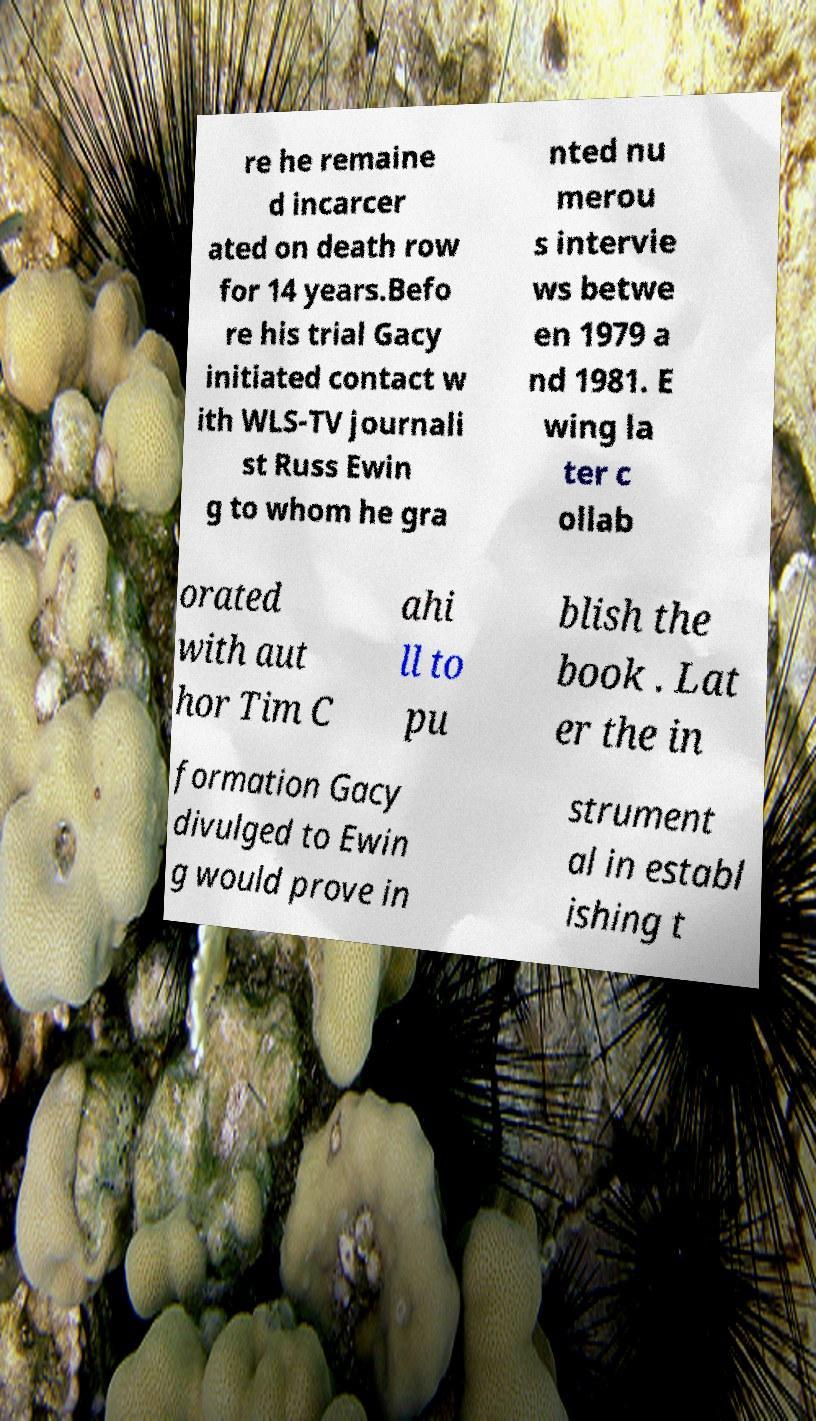What messages or text are displayed in this image? I need them in a readable, typed format. re he remaine d incarcer ated on death row for 14 years.Befo re his trial Gacy initiated contact w ith WLS-TV journali st Russ Ewin g to whom he gra nted nu merou s intervie ws betwe en 1979 a nd 1981. E wing la ter c ollab orated with aut hor Tim C ahi ll to pu blish the book . Lat er the in formation Gacy divulged to Ewin g would prove in strument al in establ ishing t 